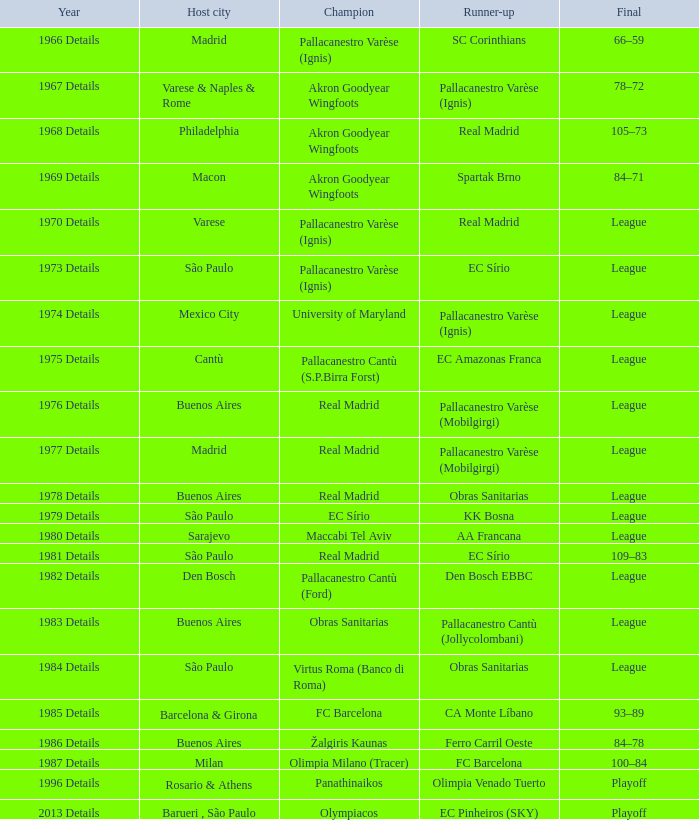During which year did the international cup take place, where akron goodyear wingfoots claimed victory and real madrid secured the second position? 1968 Details. 